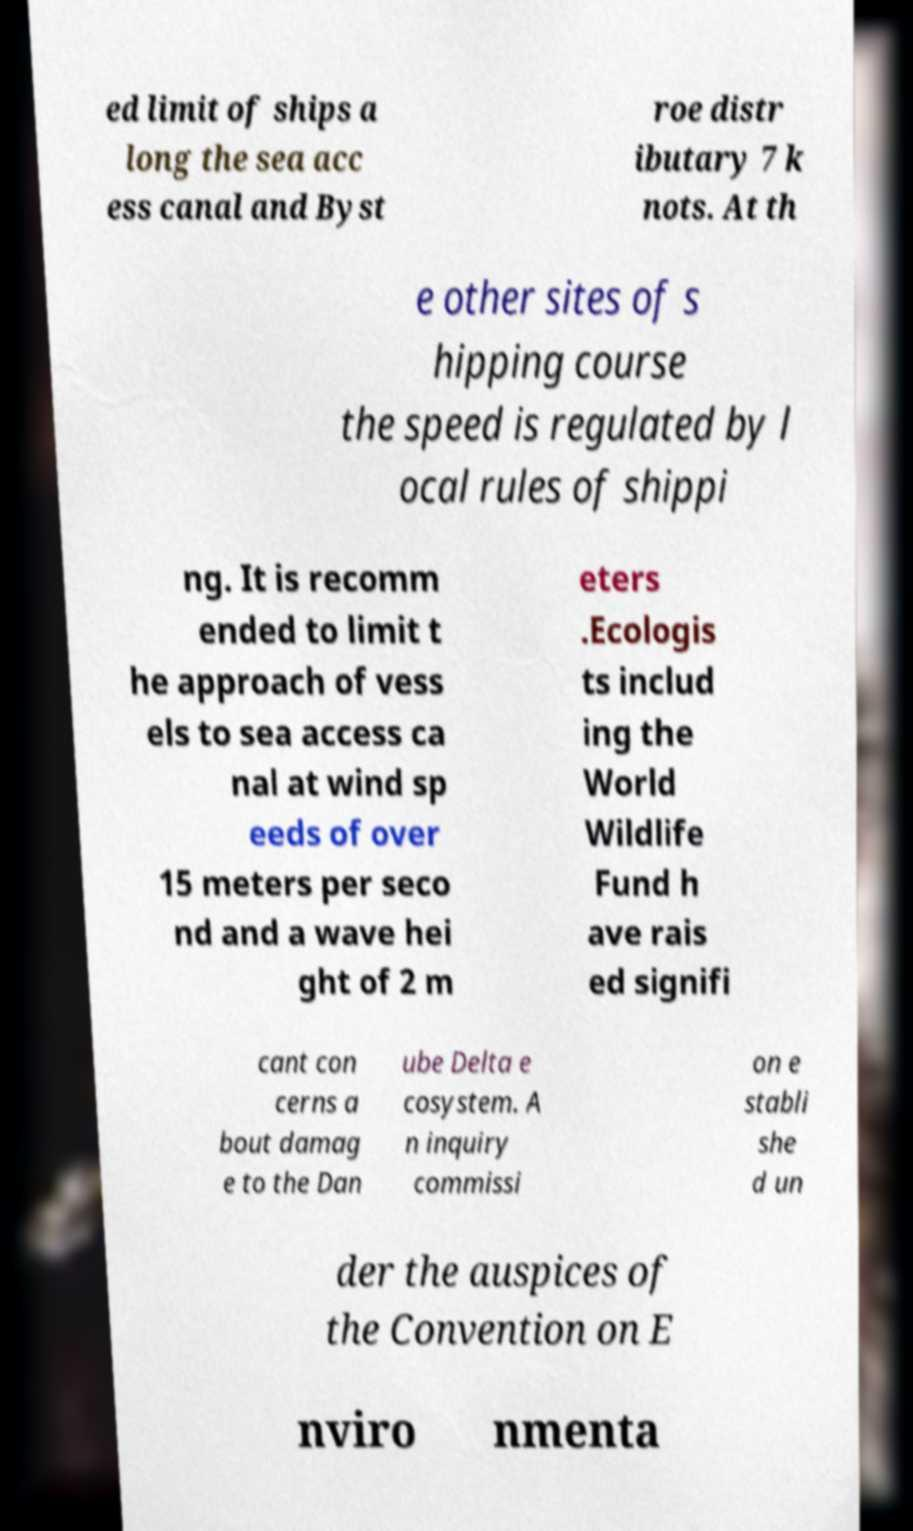There's text embedded in this image that I need extracted. Can you transcribe it verbatim? ed limit of ships a long the sea acc ess canal and Byst roe distr ibutary 7 k nots. At th e other sites of s hipping course the speed is regulated by l ocal rules of shippi ng. It is recomm ended to limit t he approach of vess els to sea access ca nal at wind sp eeds of over 15 meters per seco nd and a wave hei ght of 2 m eters .Ecologis ts includ ing the World Wildlife Fund h ave rais ed signifi cant con cerns a bout damag e to the Dan ube Delta e cosystem. A n inquiry commissi on e stabli she d un der the auspices of the Convention on E nviro nmenta 